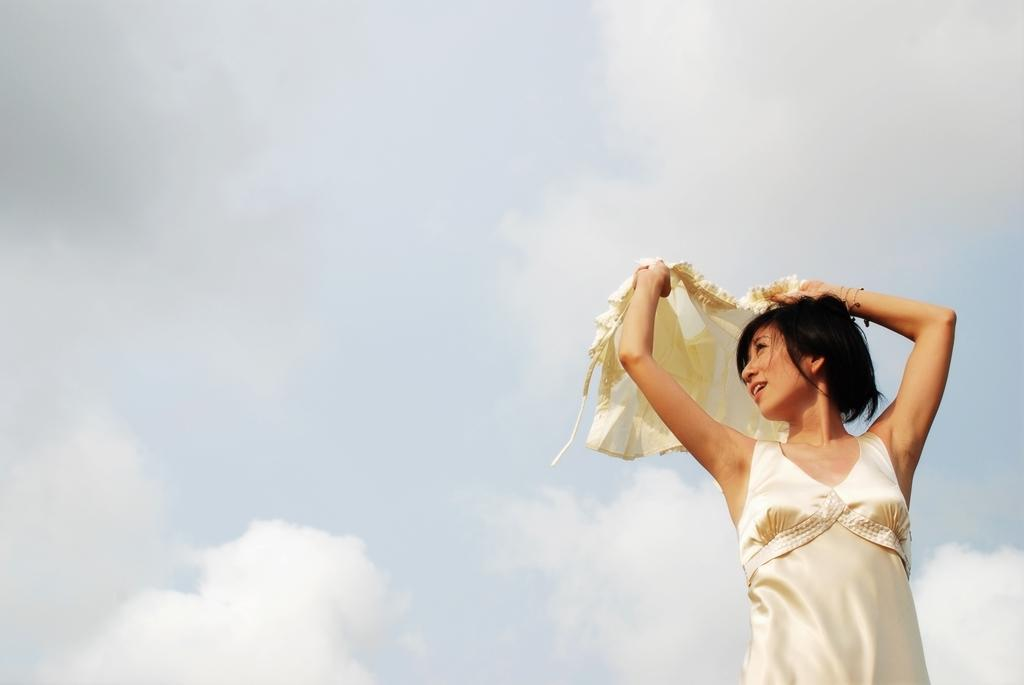Who is the main subject in the image? There is a lady in the image. What is the lady holding in her hand? The lady is holding a cloth in her hand. What is the condition of the sky in the image? There is a cloudy sky in the image. What is the mother doing with the crying baby in the image? There is no mother or baby present in the image; it only features a lady holding a cloth. 